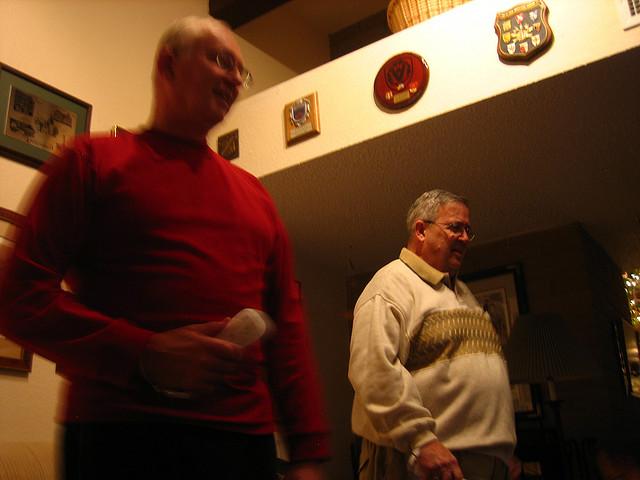What is the estimated combined age of the two players?
Concise answer only. 120. Are they playing Wii?
Concise answer only. Yes. Is the man in red left- or right-handed?
Concise answer only. Right. 